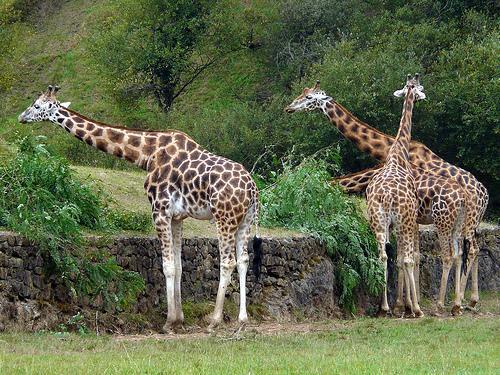How many animals are present?
Give a very brief answer. 4. 